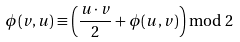<formula> <loc_0><loc_0><loc_500><loc_500>\phi ( v , u ) \equiv \left ( \frac { u \cdot v } { 2 } + \phi ( u , v ) \right ) \bmod { 2 }</formula> 